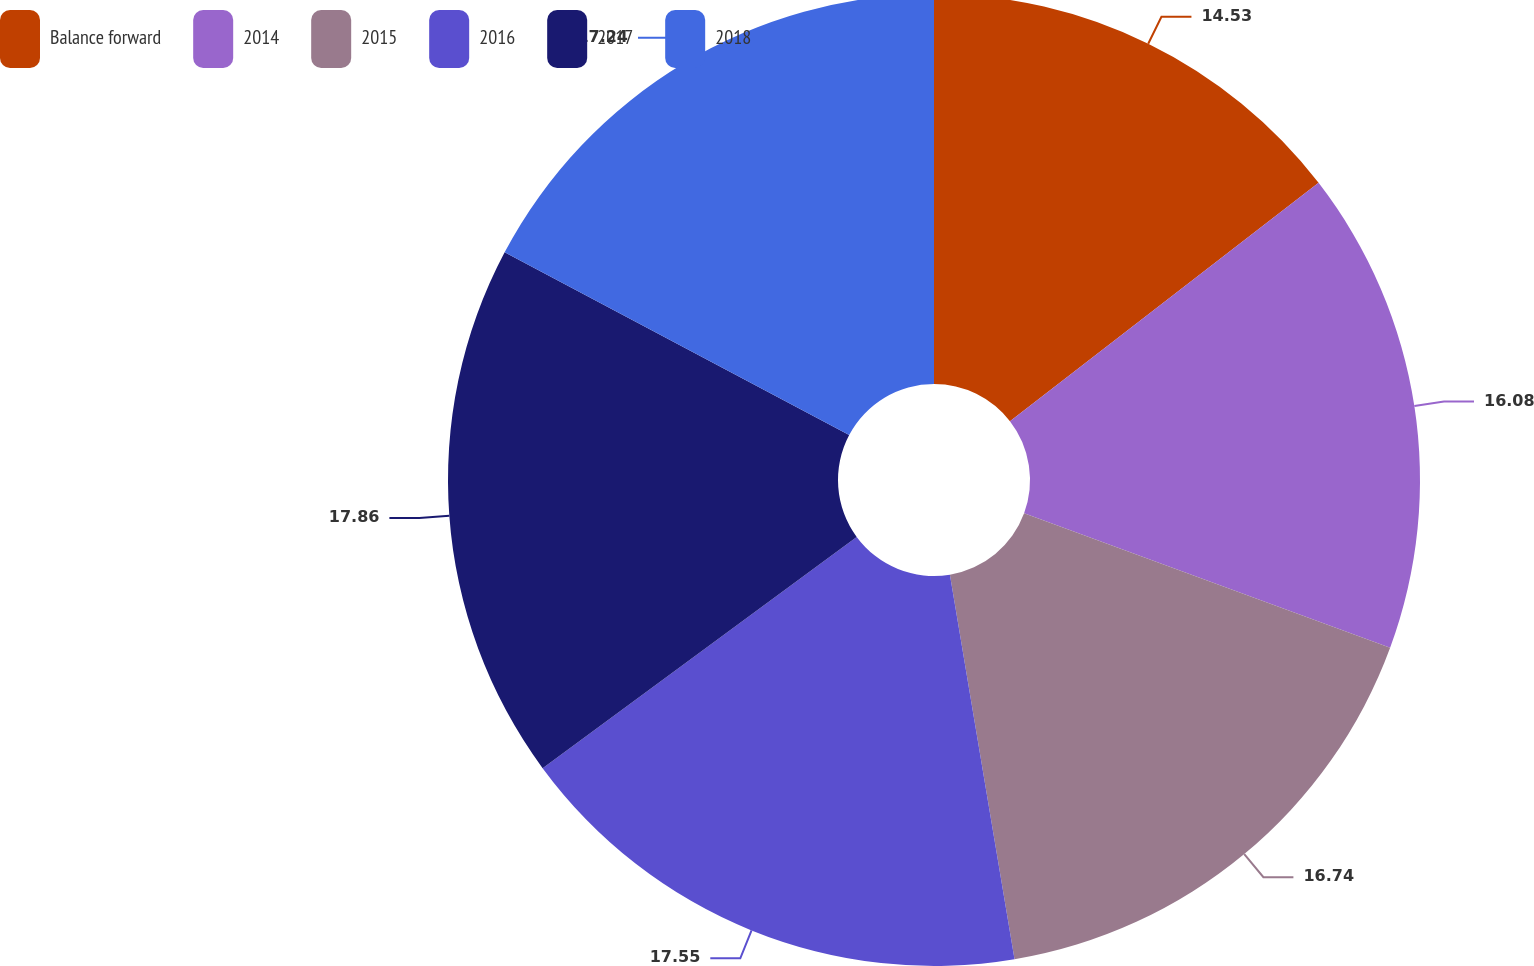Convert chart to OTSL. <chart><loc_0><loc_0><loc_500><loc_500><pie_chart><fcel>Balance forward<fcel>2014<fcel>2015<fcel>2016<fcel>2017<fcel>2018<nl><fcel>14.53%<fcel>16.08%<fcel>16.74%<fcel>17.55%<fcel>17.86%<fcel>17.24%<nl></chart> 